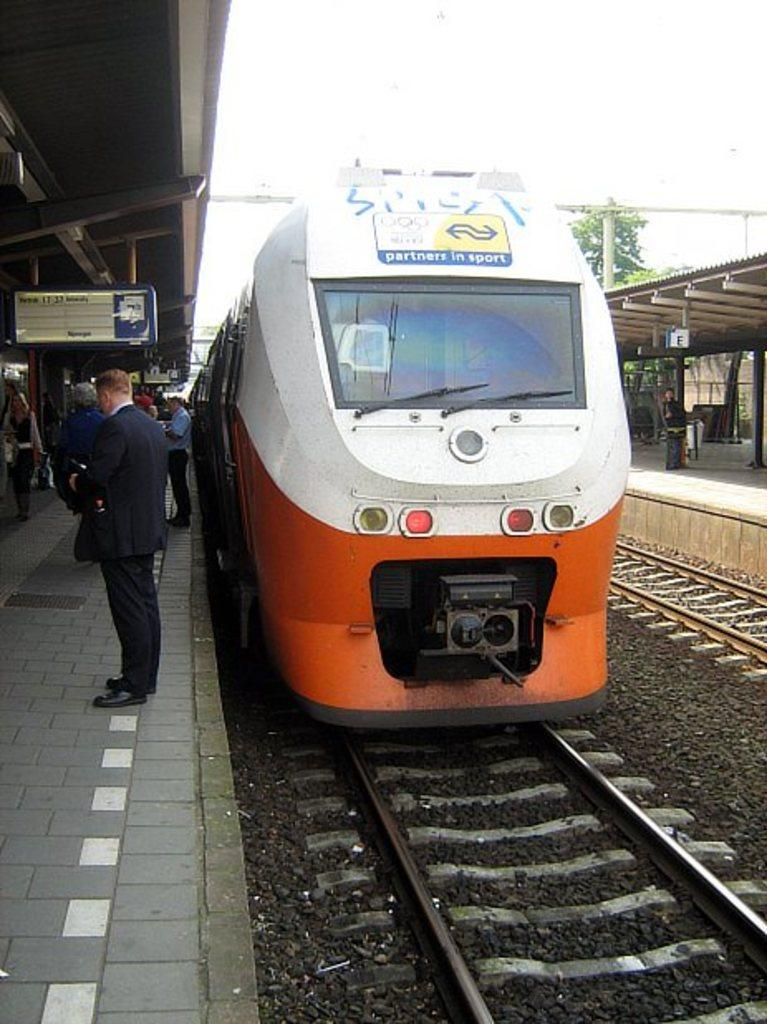What can be seen on the railway tracks in the image? There is a train on one of the railway tracks. What is happening on the platforms in the image? There are people on the platforms. What type of information might be conveyed by the sign boards in the image? The sign boards hanging from the roof of the platforms might convey information about train schedules, routes, or safety instructions. What structures are visible in the image? There are poles visible in the image. What type of vegetation can be seen in the image? There is a tree in the image. What musical instrument is being played by the tree in the image? There is no musical instrument being played by the tree in the image, as trees do not have the ability to play instruments. 